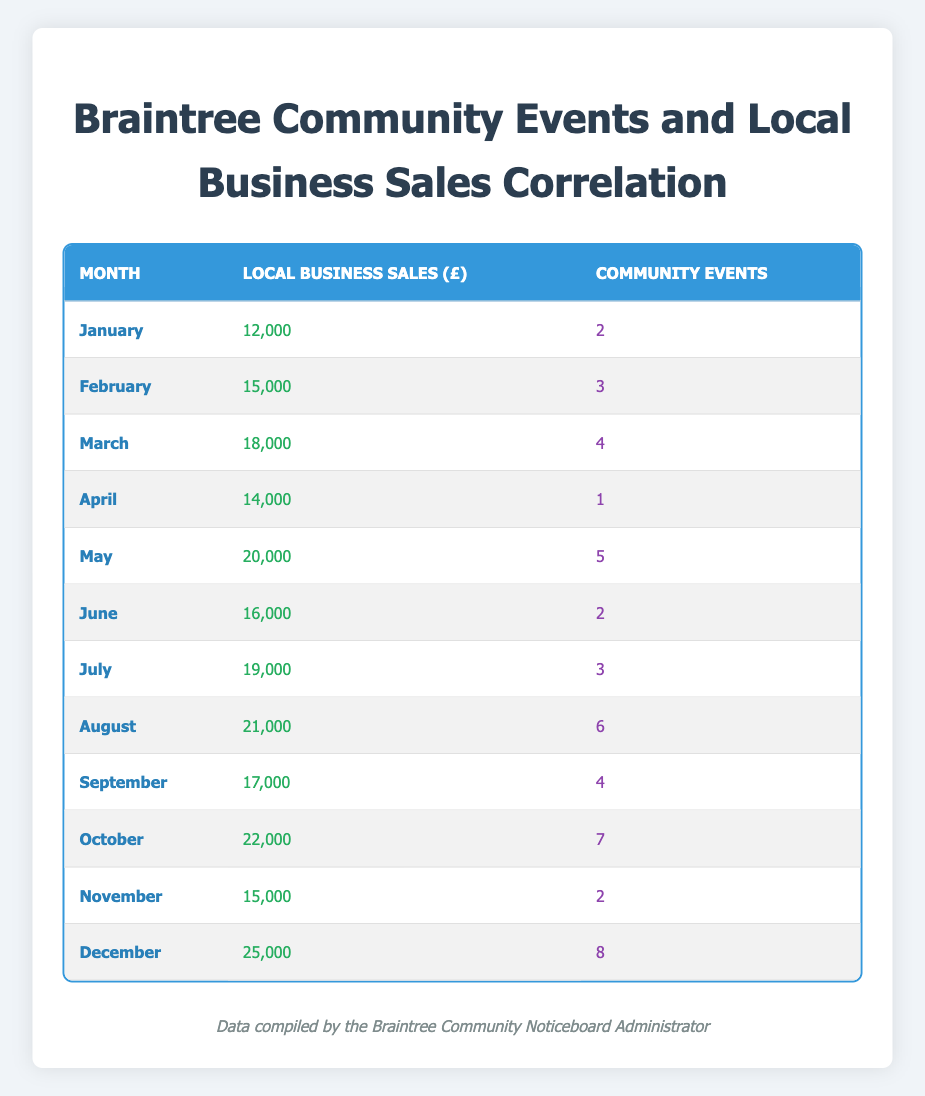What were the local business sales in July? The table shows that the local business sales in July were £19,000, which is stated directly in the sales column for that month.
Answer: £19,000 How many community events were hosted in October? According to the table, October had 7 community events listed in the events column for that month.
Answer: 7 Which month had the highest local business sales? By scanning the local business sales column, December with sales of £25,000 is the highest value among all months listed.
Answer: December What is the total number of community events over the year? To find the total, we sum the number of events in each month: 2 + 3 + 4 + 1 + 5 + 2 + 3 + 6 + 4 + 7 + 2 + 8 = 47. Therefore, the total number of community events over the year is 47.
Answer: 47 Did local business sales increase every month? No, examining the sales column reveals fluctuations; for example, sales decreased from March (£18,000) to April (£14,000), indicating not every month saw an increase.
Answer: No What was the average amount of local business sales for the months listed? The total local business sales are calculated by summing all monthly sales: 12000 + 15000 + 18000 + 14000 + 20000 + 16000 + 19000 + 21000 + 17000 + 22000 + 15000 + 25000 = 207000. Dividing this by 12 months gives an average of 207000 / 12 = £17,250.
Answer: £17,250 In which month did Braintree have the lowest number of community events? Looking at the events column, April has the lowest number of community events with only 1 event hosted that month.
Answer: April Was there a month with local business sales below £15,000? Yes, according to the sales column, both January (£12,000) and April (£14,000) show local business sales below £15,000.
Answer: Yes What is the difference in local business sales between December and January? Local business sales in December are £25,000 and in January are £12,000. The difference is calculated as 25000 - 12000 = £13,000.
Answer: £13,000 